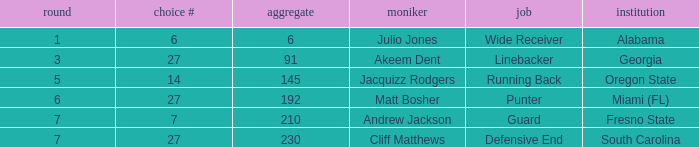Which highest pick number had Akeem Dent as a name and where the overall was less than 91? None. 